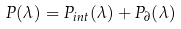Convert formula to latex. <formula><loc_0><loc_0><loc_500><loc_500>P ( \lambda ) = P _ { i n t } ( \lambda ) + P _ { \partial } ( \lambda )</formula> 